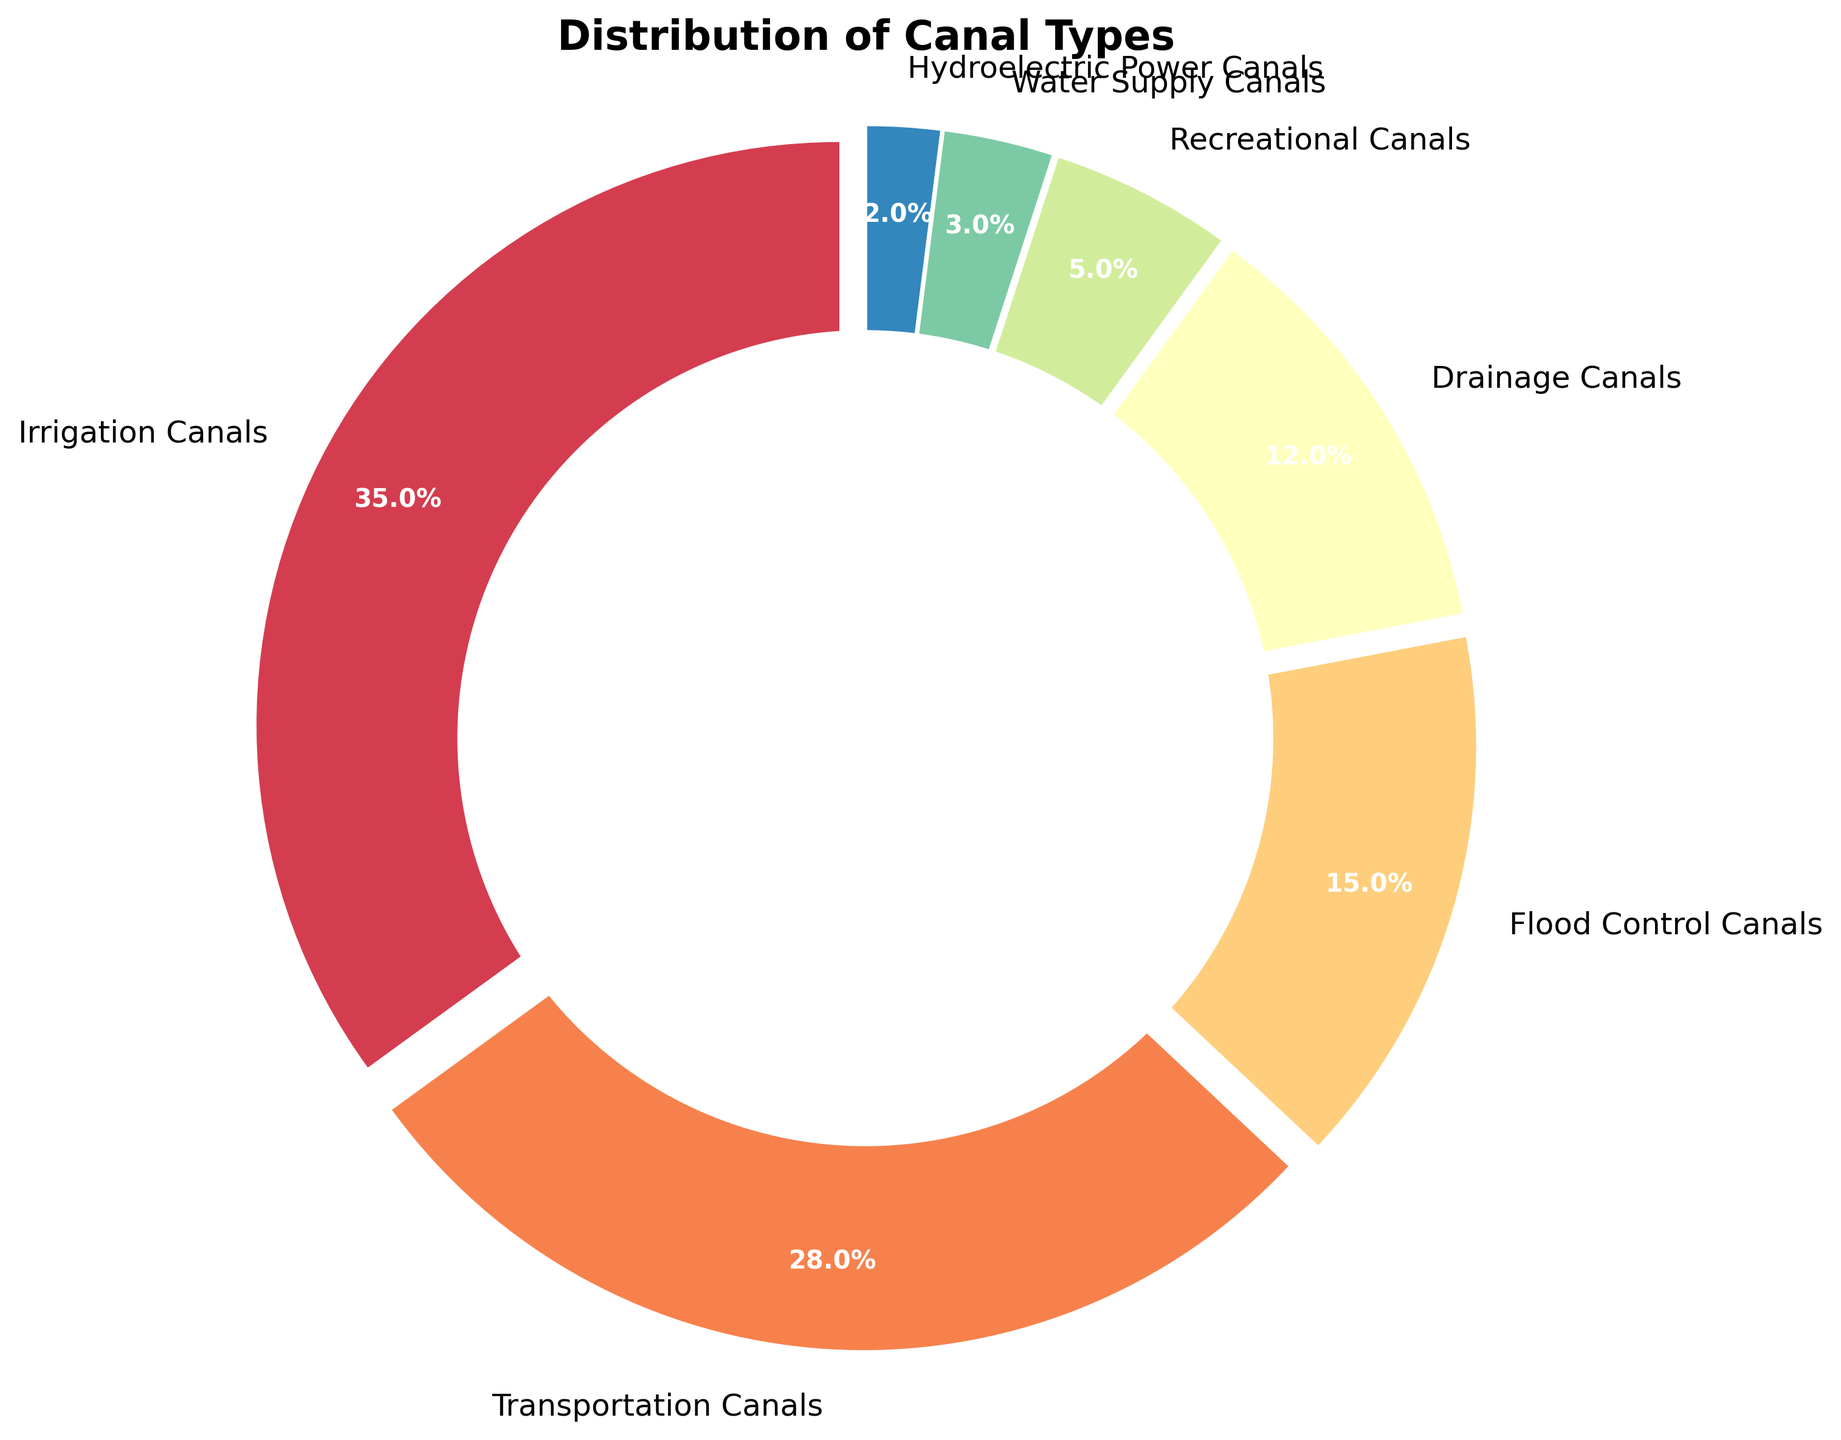What is the total percentage of canals used for irrigation, transportation, and flood control? To find the total percentage of canals used for irrigation, transportation, and flood control, simply sum the percentages of these canal types: Irrigation Canals (35%) + Transportation Canals (28%) + Flood Control Canals (15%) = 78%
Answer: 78% Which type of canal has the smallest percentage share? By examining the figure, the Hydroelectric Power Canals have the smallest section of the pie chart, which represents 2% of the total
Answer: Hydroelectric Power Canals How does the percentage of recreational canals compare to the percentage of irrigation canals? Recreational Canals have a 5% share, while Irrigation Canals have a 35% share. Hence, Irrigation Canals have a significantly larger share than Recreational Canals
Answer: Irrigation Canals have a larger share What is the combined percentage of drainage canals and water supply canals? To find the combined percentage, add the percentages of Drainage Canals and Water Supply Canals: Drainage Canals (12%) + Water Supply Canals (3%) = 15%
Answer: 15% Which canal type has a visual representation with a color most closely resembling red? By referring to the color scheme used in the pie chart, we can visually match the color closest to red with the corresponding label. Let’s assume the exact color scheme aligns with Recreational Canals being in a red hue.
Answer: Recreational Canals If the region decides to equally divide the percentage of recreational canals and hydroelectric power canals among the other canal types, what would be the new percentage for transportation canals? First, find the total percentage share of Recreational (5%) and Hydroelectric Power Canals (2%), giving 7%. Dividing this equally among the 5 remaining types, we get an increase of 7%/5 = 1.4% for each. Adding this to the current Transportation Canals percentage: 28% + 1.4% = 29.4%
Answer: 29.4% Which canal types together make up more than half of the total percentage? Summing up the top canal types one by one until surpassing 50%: Irrigation Canals (35%) + Transportation Canals (28%) = 63%, so these two alone make up more than half
Answer: Irrigation and Transportation Canals What is the difference in percentage between the flood control canals and transportation canals? The difference can be calculated by subtracting the percentage of Flood Control Canals (15%) from Transportation Canals (28%): 28% - 15% = 13%
Answer: 13% Which category occupies the largest segment of the pie chart? By visual assessment, the Irrigation Canals have the largest segment occupying 35%
Answer: Irrigation Canals If combined, what percentage do the recreational, water supply, and hydroelectric power canals contribute? Summing the percentages of Recreational (5%), Water Supply (3%), and Hydroelectric Power Canals (2%): 5% + 3% + 2% = 10%
Answer: 10% 